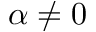<formula> <loc_0><loc_0><loc_500><loc_500>\alpha \ne 0</formula> 